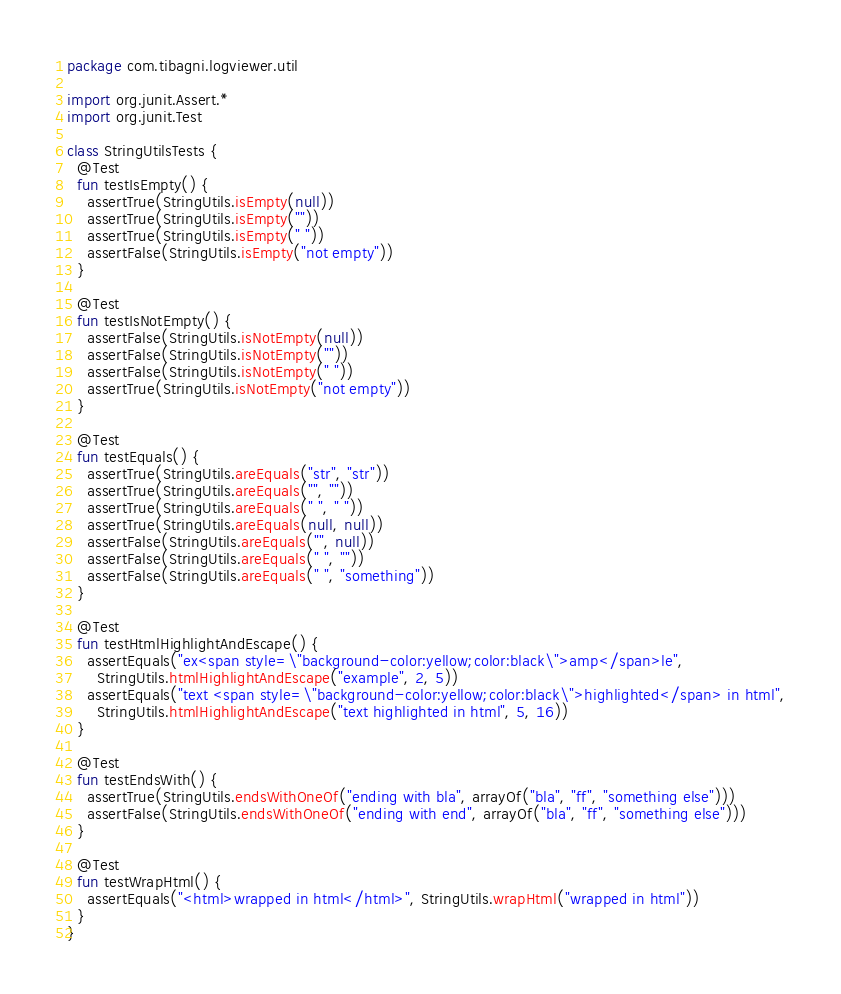<code> <loc_0><loc_0><loc_500><loc_500><_Kotlin_>package com.tibagni.logviewer.util

import org.junit.Assert.*
import org.junit.Test

class StringUtilsTests {
  @Test
  fun testIsEmpty() {
    assertTrue(StringUtils.isEmpty(null))
    assertTrue(StringUtils.isEmpty(""))
    assertTrue(StringUtils.isEmpty(" "))
    assertFalse(StringUtils.isEmpty("not empty"))
  }

  @Test
  fun testIsNotEmpty() {
    assertFalse(StringUtils.isNotEmpty(null))
    assertFalse(StringUtils.isNotEmpty(""))
    assertFalse(StringUtils.isNotEmpty(" "))
    assertTrue(StringUtils.isNotEmpty("not empty"))
  }

  @Test
  fun testEquals() {
    assertTrue(StringUtils.areEquals("str", "str"))
    assertTrue(StringUtils.areEquals("", ""))
    assertTrue(StringUtils.areEquals(" ", " "))
    assertTrue(StringUtils.areEquals(null, null))
    assertFalse(StringUtils.areEquals("", null))
    assertFalse(StringUtils.areEquals(" ", ""))
    assertFalse(StringUtils.areEquals(" ", "something"))
  }

  @Test
  fun testHtmlHighlightAndEscape() {
    assertEquals("ex<span style=\"background-color:yellow;color:black\">amp</span>le",
      StringUtils.htmlHighlightAndEscape("example", 2, 5))
    assertEquals("text <span style=\"background-color:yellow;color:black\">highlighted</span> in html",
      StringUtils.htmlHighlightAndEscape("text highlighted in html", 5, 16))
  }

  @Test
  fun testEndsWith() {
    assertTrue(StringUtils.endsWithOneOf("ending with bla", arrayOf("bla", "ff", "something else")))
    assertFalse(StringUtils.endsWithOneOf("ending with end", arrayOf("bla", "ff", "something else")))
  }

  @Test
  fun testWrapHtml() {
    assertEquals("<html>wrapped in html</html>", StringUtils.wrapHtml("wrapped in html"))
  }
}</code> 